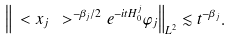<formula> <loc_0><loc_0><loc_500><loc_500>\left \| \ < x _ { j } \ > ^ { - \beta _ { j } / 2 } e ^ { - i t H _ { 0 } ^ { j } } \varphi _ { j } \right \| _ { L ^ { 2 } } \lesssim t ^ { - \beta _ { j } } .</formula> 